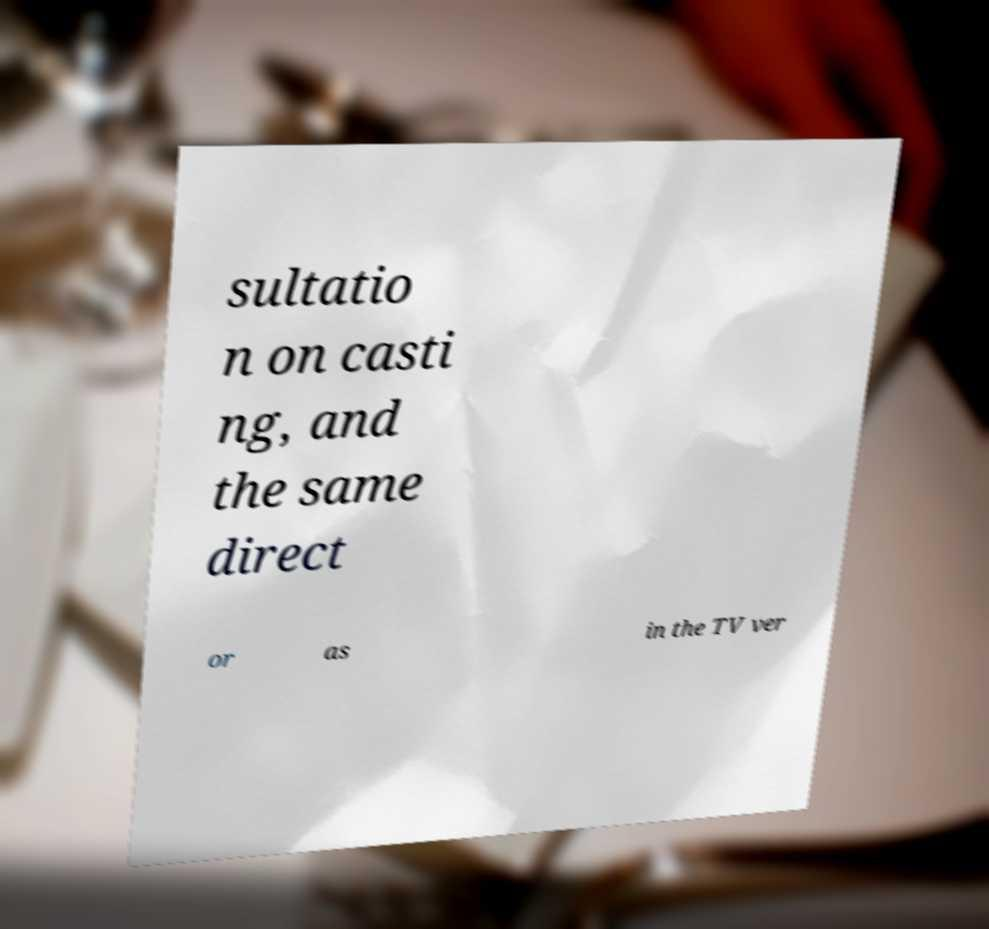What messages or text are displayed in this image? I need them in a readable, typed format. sultatio n on casti ng, and the same direct or as in the TV ver 